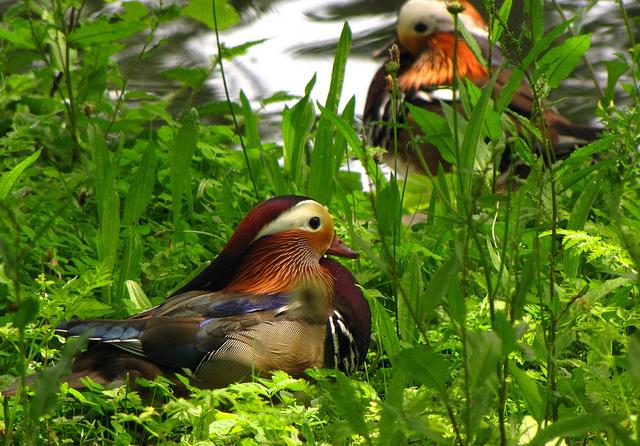What type of bird is this?
Concise answer only. Duck. Is the bird nesting here?
Answer briefly. Yes. How many birds are visible?
Give a very brief answer. 2. 